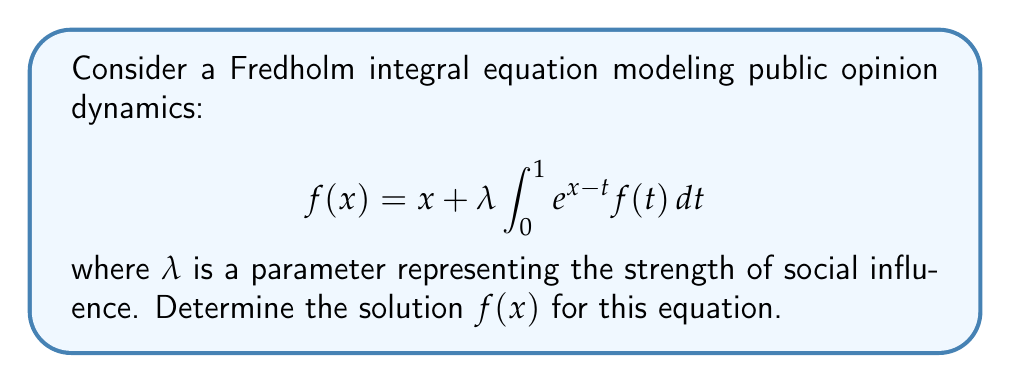Solve this math problem. To solve this Fredholm integral equation, we'll follow these steps:

1) First, let's assume a solution of the form:
   $$f(x) = Ae^x + Bx + C$$
   where A, B, and C are constants to be determined.

2) Substitute this into the right-hand side of the equation:
   $$x + \lambda \int_0^1 e^{x-t} (Ae^t + Bt + C) dt$$

3) Evaluate the integral:
   $$x + \lambda [Ae^x \int_0^1 e^{-t} dt + B \int_0^1 te^{x-t} dt + C \int_0^1 e^{x-t} dt]$$
   $$= x + \lambda [Ae^x (1-e^{-1}) + B(e^x - x - 1) + C(e^x - 1)]$$

4) Simplify:
   $$= x + \lambda Ae^x - \lambda Ae^{x-1} + \lambda Be^x - \lambda Bx - \lambda B + \lambda Ce^x - \lambda C$$
   $$= (\lambda A + \lambda B + \lambda C)e^x + (1-\lambda B)x + (-\lambda Ae^{-1} - \lambda B - \lambda C)$$

5) For this to be identical to our assumed solution, we must have:
   $$\lambda A + \lambda B + \lambda C = A$$
   $$1 - \lambda B = B$$
   $$-\lambda Ae^{-1} - \lambda B - \lambda C = C$$

6) From the second equation:
   $$B = \frac{1}{1+\lambda}$$

7) From the first equation:
   $$A(1-\lambda) = \lambda B + \lambda C$$
   $$A = \frac{\lambda B + \lambda C}{1-\lambda} = \frac{\lambda}{(1-\lambda)(1+\lambda)} + \frac{\lambda C}{1-\lambda}$$

8) Substitute these into the third equation:
   $$-\lambda (\frac{\lambda}{(1-\lambda)(1+\lambda)} + \frac{\lambda C}{1-\lambda})e^{-1} - \frac{\lambda}{1+\lambda} - \lambda C = C$$

9) Solve for C:
   $$C = -\frac{\lambda e^{-1}}{(1-\lambda)(1+\lambda)} - \frac{\lambda}{1+\lambda}$$

10) Now we have all our constants. The solution is:
    $$f(x) = \frac{\lambda}{(1-\lambda)(1+\lambda)}e^x + \frac{1}{1+\lambda}x - \frac{\lambda e^{-1}}{(1-\lambda)(1+\lambda)} - \frac{\lambda}{1+\lambda}$$
Answer: $f(x) = \frac{\lambda}{(1-\lambda)(1+\lambda)}e^x + \frac{1}{1+\lambda}x - \frac{\lambda e^{-1}}{(1-\lambda)(1+\lambda)} - \frac{\lambda}{1+\lambda}$ 